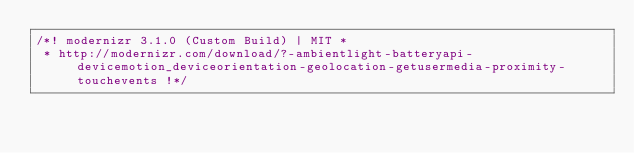Convert code to text. <code><loc_0><loc_0><loc_500><loc_500><_JavaScript_>/*! modernizr 3.1.0 (Custom Build) | MIT *
 * http://modernizr.com/download/?-ambientlight-batteryapi-devicemotion_deviceorientation-geolocation-getusermedia-proximity-touchevents !*/</code> 